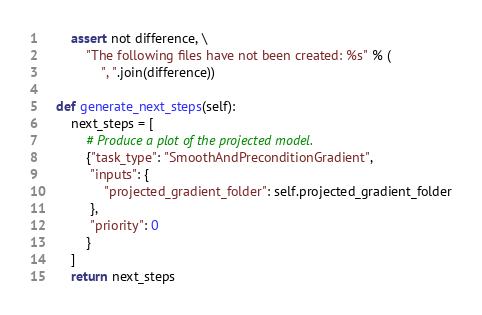<code> <loc_0><loc_0><loc_500><loc_500><_Python_>
        assert not difference, \
            "The following files have not been created: %s" % (
                ", ".join(difference))

    def generate_next_steps(self):
        next_steps = [
            # Produce a plot of the projected model.
            {"task_type": "SmoothAndPreconditionGradient",
             "inputs": {
                 "projected_gradient_folder": self.projected_gradient_folder
             },
             "priority": 0
            }
        ]
        return next_steps
</code> 